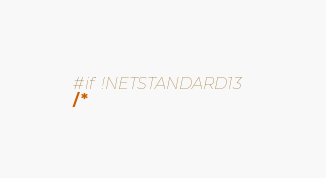Convert code to text. <code><loc_0><loc_0><loc_500><loc_500><_C#_>#if !NETSTANDARD13
/*</code> 